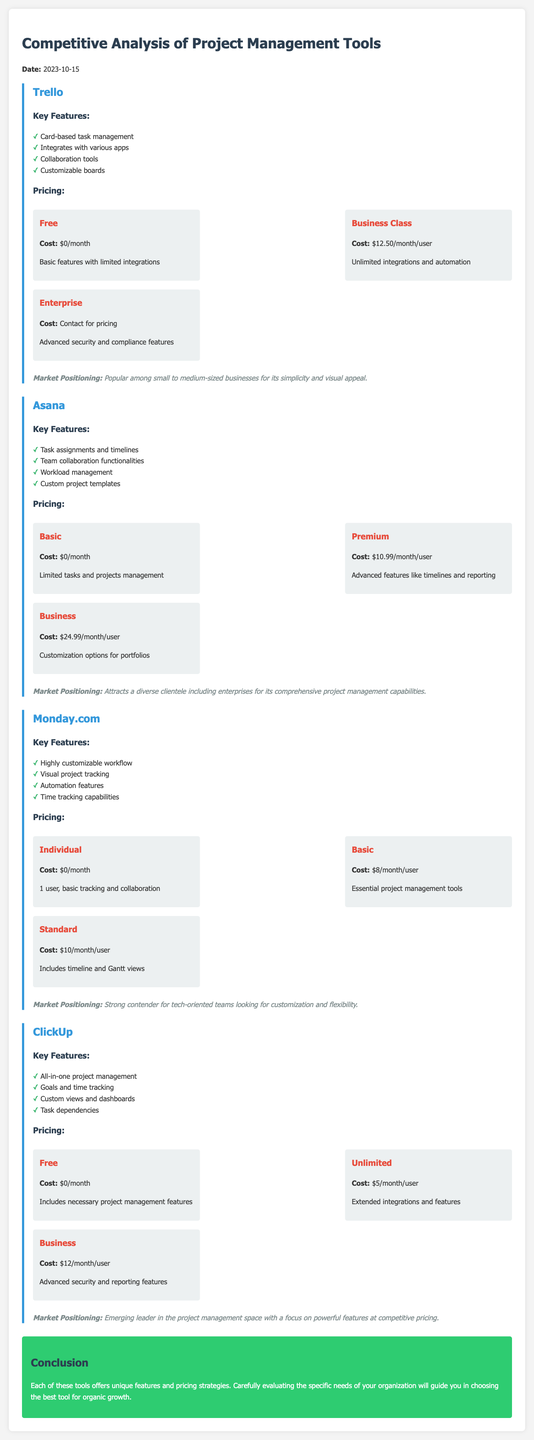What are the key features of Trello? The key features of Trello are listed in the document under Trello's section, which includes card-based task management, integration with various apps, collaboration tools, and customizable boards.
Answer: Card-based task management, integrates with various apps, collaboration tools, customizable boards What is the pricing for Asana's Premium plan? The document specifies the cost of Asana's Premium plan under its pricing section, which is $10.99 per month per user.
Answer: $10.99/month/user Which tool offers advanced security and compliance features? The document indicates that the Enterprise plan of Trello includes advanced security and compliance features.
Answer: Trello How much does ClickUp's Unlimited plan cost? The document states the cost for ClickUp's Unlimited plan under its pricing section, which is $5 per month per user.
Answer: $5/month/user What is the market positioning of Monday.com? The document highlights the market positioning of Monday.com as a strong contender for tech-oriented teams looking for customization and flexibility.
Answer: Strong contender for tech-oriented teams Which product is popular among small to medium-sized businesses? The document notes that Trello is popular among small to medium-sized businesses for its simplicity and visual appeal.
Answer: Trello How many pricing plans does ClickUp offer? The document lists three pricing plans for ClickUp: Free, Unlimited, and Business, indicating a total of three plans.
Answer: 3 What feature differentiates Asana from Trello? Asana includes task assignments and timelines as a key feature that is not specified for Trello, indicating it has additional project management functionalities.
Answer: Task assignments and timelines What conclusion does the document reach about the tools? The conclusion emphasizes the importance of carefully evaluating the specific needs of organizations to choose the best tool for organic growth.
Answer: Choosing the best tool for organic growth 